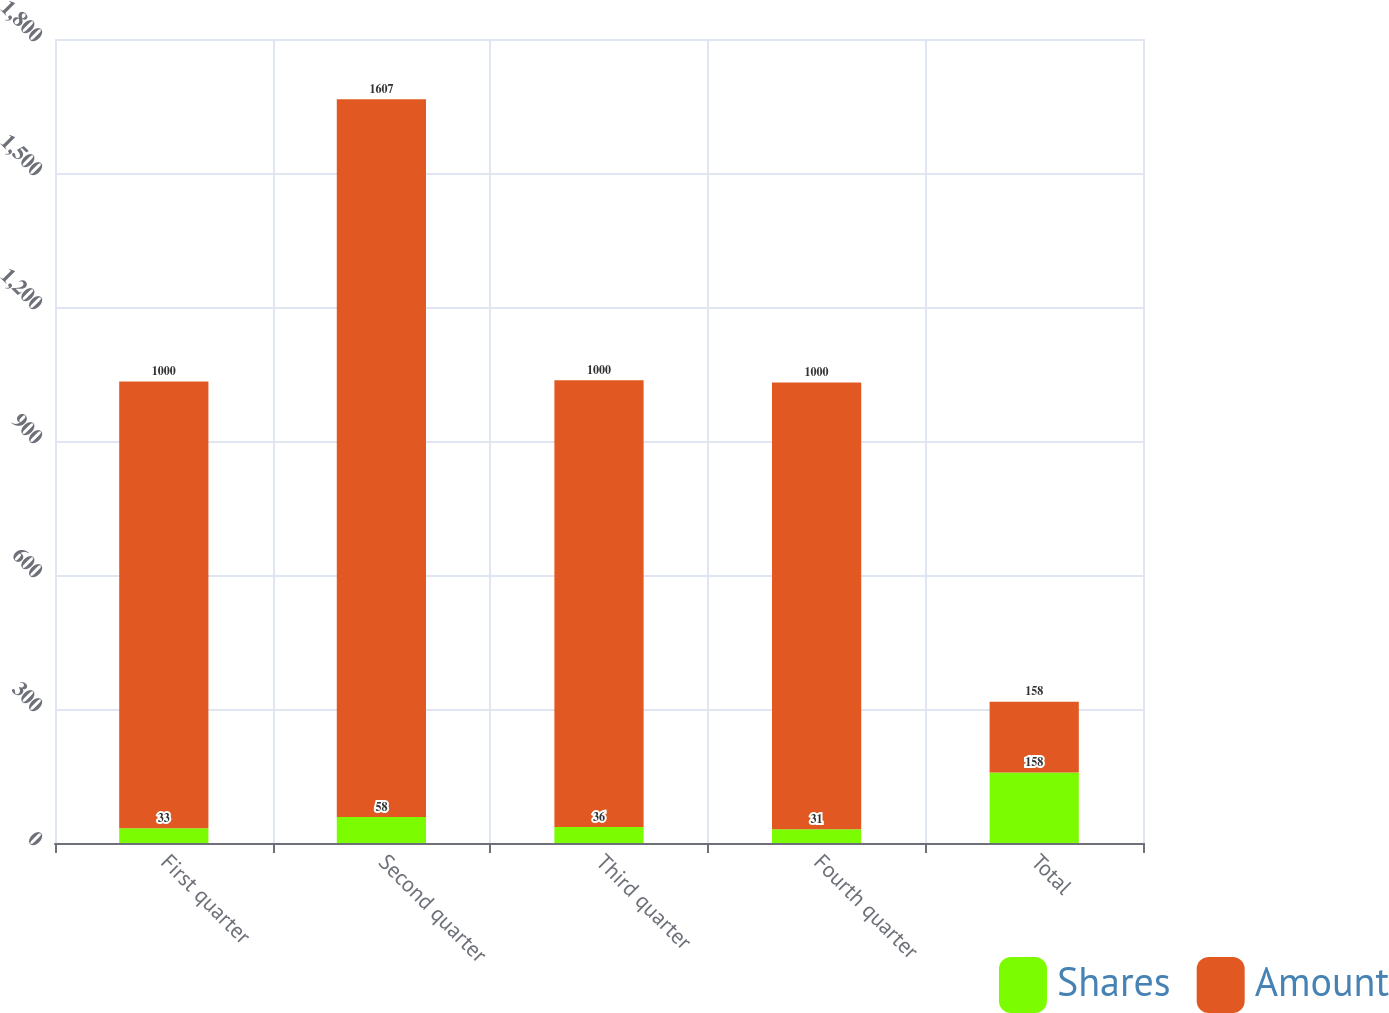Convert chart. <chart><loc_0><loc_0><loc_500><loc_500><stacked_bar_chart><ecel><fcel>First quarter<fcel>Second quarter<fcel>Third quarter<fcel>Fourth quarter<fcel>Total<nl><fcel>Shares<fcel>33<fcel>58<fcel>36<fcel>31<fcel>158<nl><fcel>Amount<fcel>1000<fcel>1607<fcel>1000<fcel>1000<fcel>158<nl></chart> 